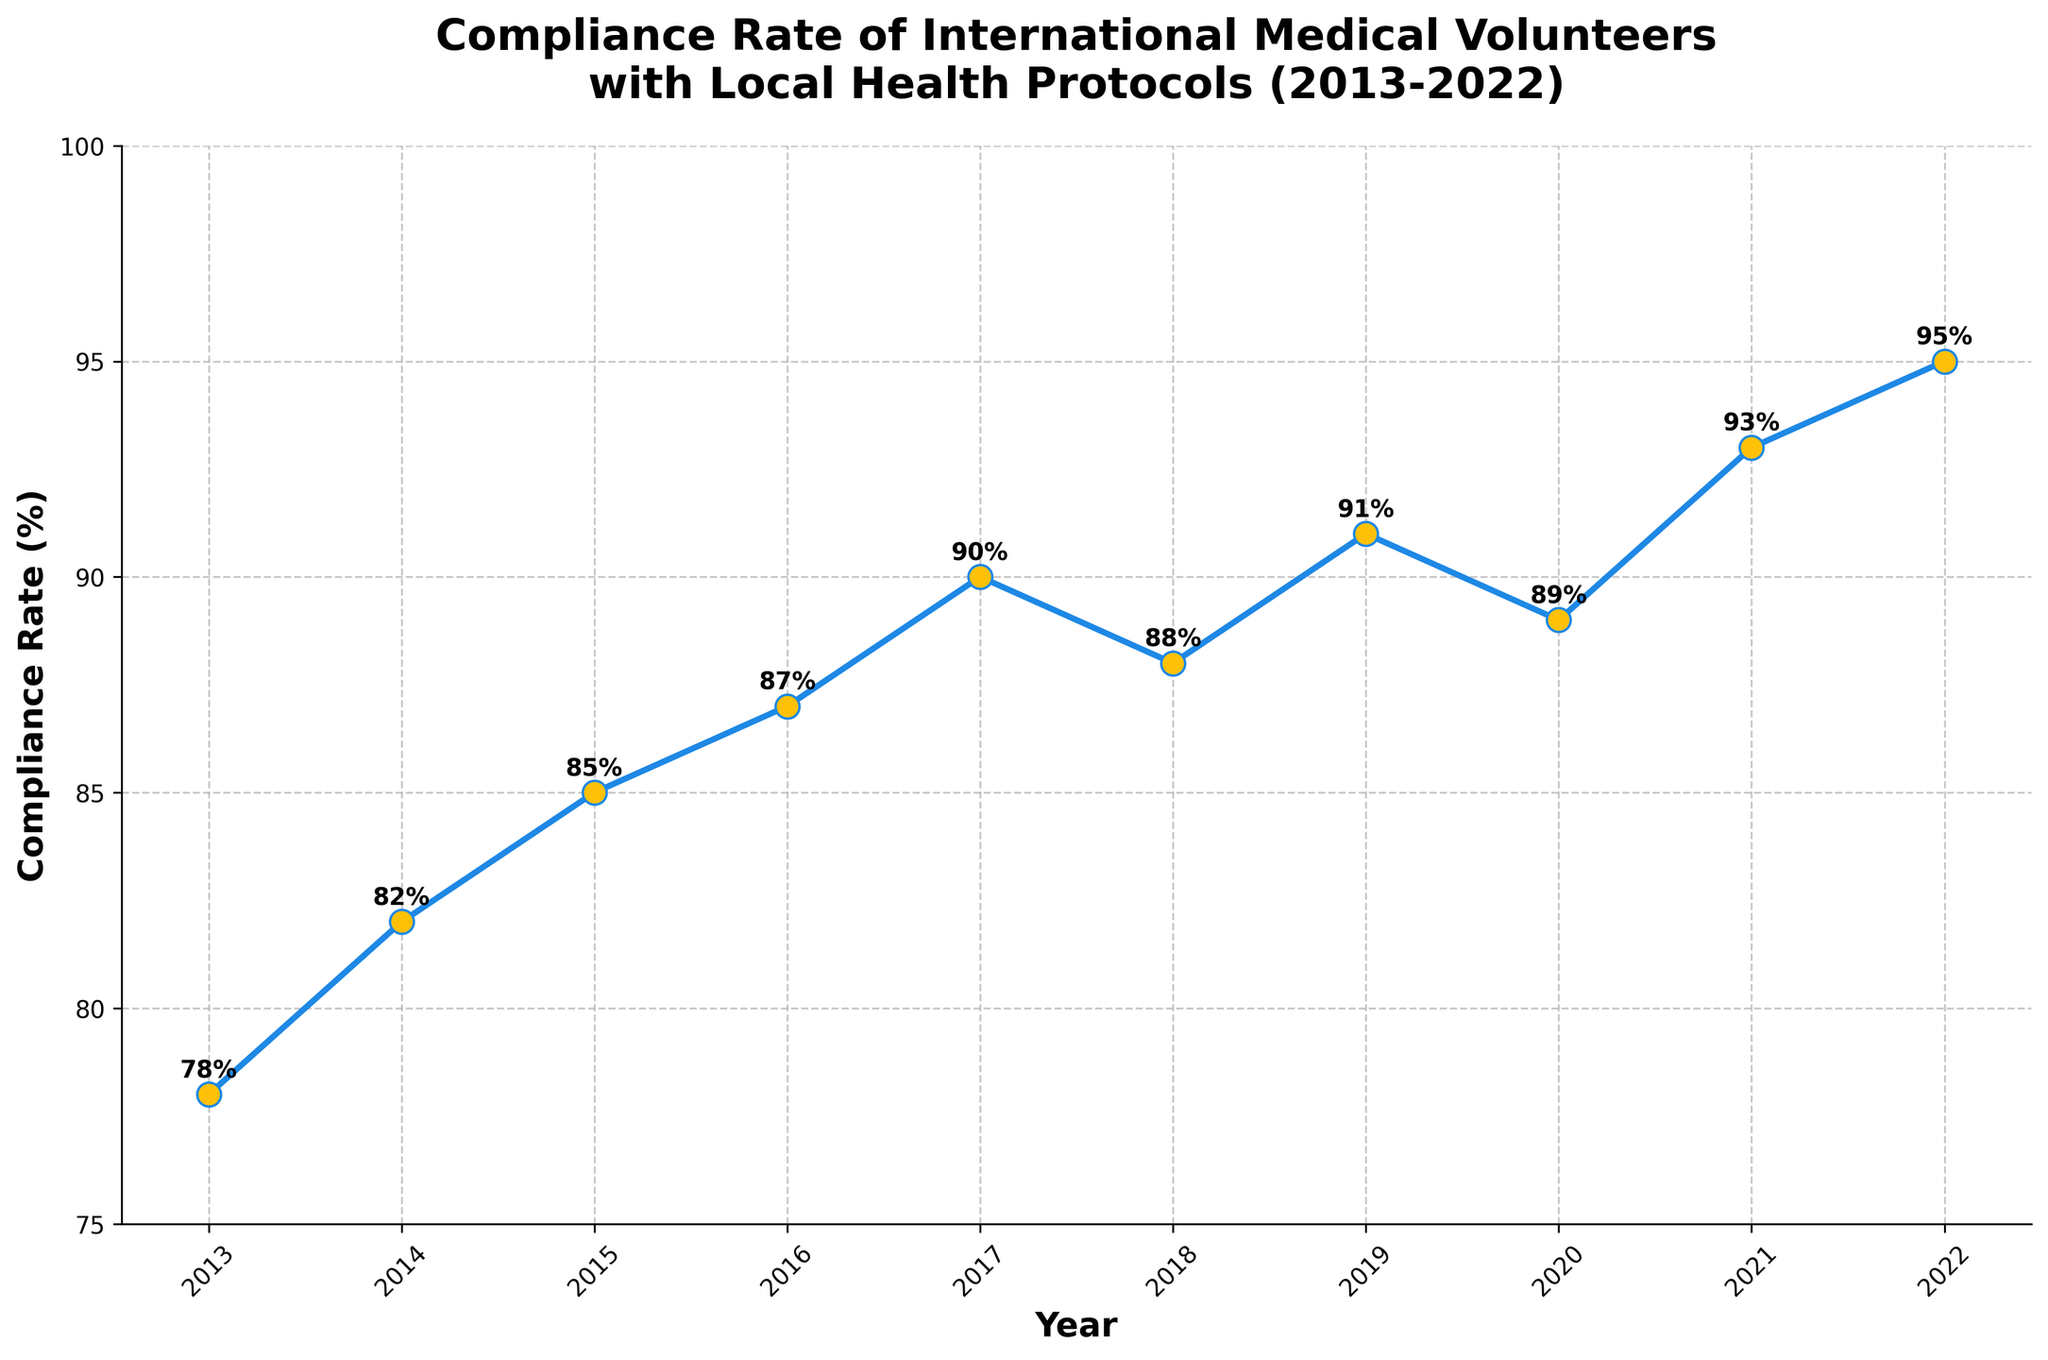What is the title of the plot? The title is usually located at the top of the plot.
Answer: Compliance Rate of International Medical Volunteers with Local Health Protocols (2013-2022) What does the y-axis represent? The y-axis represents the Compliance Rate, typically labeled on the left side of the plot.
Answer: Compliance Rate (%) How many years of data are shown in the plot? Counting the data points or x-axis ticks can give the number of years presented.
Answer: 10 What is the overall trend in compliance rates from 2013 to 2022? Look at the plotted line; it shows an upward trend indicating an increase in compliance rates over the years.
Answer: Increasing In which year was the compliance rate the highest? Identify the peak point on the plot; here, it occurs at the highest y-value.
Answer: 2022 By how much did the compliance rate increase from 2013 to 2022? Subtract the compliance rate in 2013 from that in 2022 (95% - 78%).
Answer: 17% What was the average compliance rate from 2013 to 2022? Sum all compliance rates and divide by the number of years: (78+82+85+87+90+88+91+89+93+95)/10.
Answer: 87.8% Between which two consecutive years was the largest increase in compliance rate observed? Compare the yearly differences and identify the largest change.
Answer: 2016-2017 Did the compliance rate ever decrease, and if so, in which year? Look for any downward trend between consecutive points; any year preceding a decrease is the desired answer.
Answer: 2017-2018 What is the rate of change in compliance rate from 2019 to 2020? Subtract the compliance rate of 2019 from that of 2020 and divide by the number of years (1): (89 - 91) / 1.
Answer: -2 